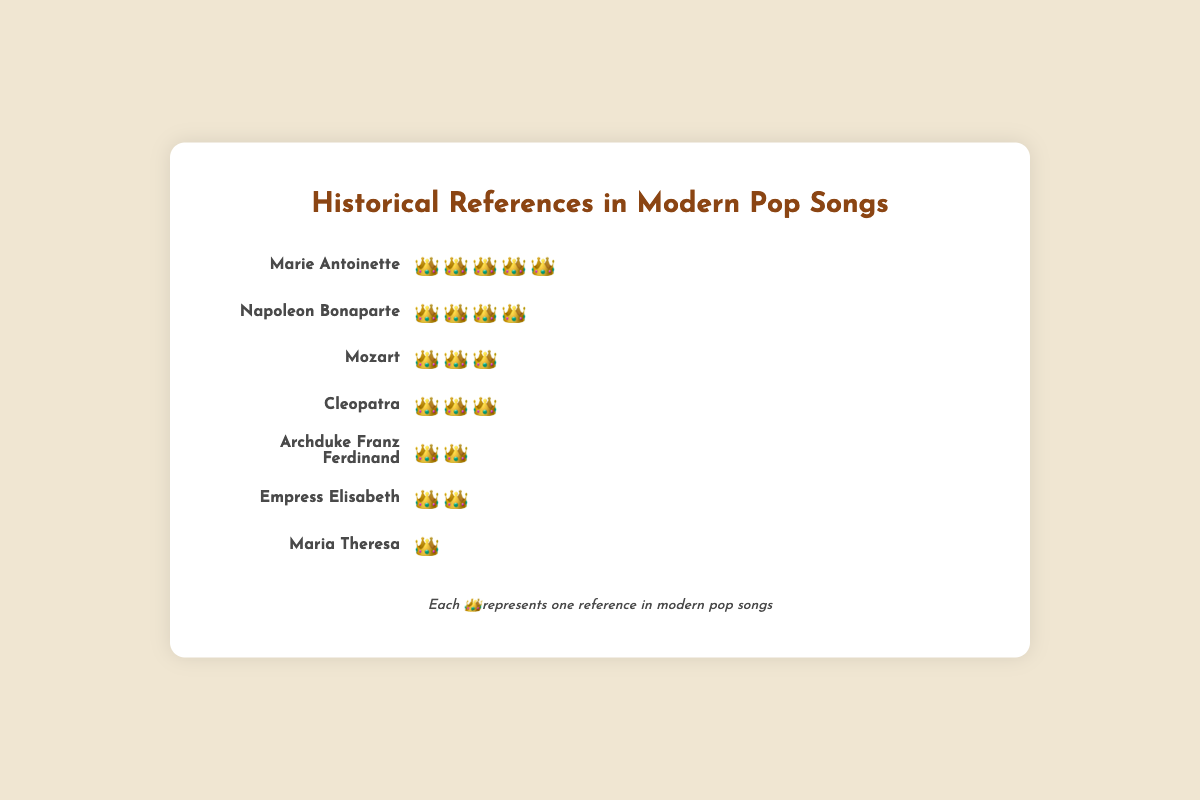Which historical figure is most frequently referenced in modern pop songs? The figure with the most crowns represents the highest frequency of references. Marie Antoinette has five crowns, which is the highest.
Answer: Marie Antoinette How many crowns indicate the frequency of mentions for Napoleon Bonaparte? Look at the row labeled "Napoleon Bonaparte" and count the crowns. There are four crowns next to his name.
Answer: 4 Which two figures are referenced equally in modern pop songs? Find the figures with the same number of crowns. Both Mozart and Cleopatra have three crowns each.
Answer: Mozart and Cleopatra Who is referenced less frequently: Empress Elisabeth or Maria Theresa? Compare the number of crowns next to each figure's name. Empress Elisabeth has two crowns, while Maria Theresa has one. So, Maria Theresa is referenced less frequently.
Answer: Maria Theresa What is the total number of crowns for Archduke Franz Ferdinand and Empress Elisabeth combined? Add the crowns for Archduke Franz Ferdinand and Empress Elisabeth. Archduke Franz Ferdinand has two crowns, and Empress Elisabeth has two as well. 2 + 2 = 4.
Answer: 4 How many more references does Marie Antoinette have compared to Archduke Franz Ferdinand? Subtract the number of crowns for Archduke Franz Ferdinand from Marie Antoinette’s crowns. Marie Antoinette has five crowns, and Archduke Franz Ferdinand has two. 5 - 2 = 3.
Answer: 3 Which historical figure mentioned has the fewest references? The figure with the least number of crowns depicts the fewest references. Maria Theresa has only one crown.
Answer: Maria Theresa Are there any figures with exactly three references? Check the number of crowns and see if any figure has precisely three crowns. Both Mozart and Cleopatra each have three crowns.
Answer: Yes What is the average number of crowns for the figures listed? To find the average, add up all crowns and divide by the number of figures. Total crowns: 5 + 4 + 3 + 3 + 2 + 2 + 1 = 20. Number of figures: 7. Average = 20 / 7 ≈ 2.86.
Answer: 2.86 